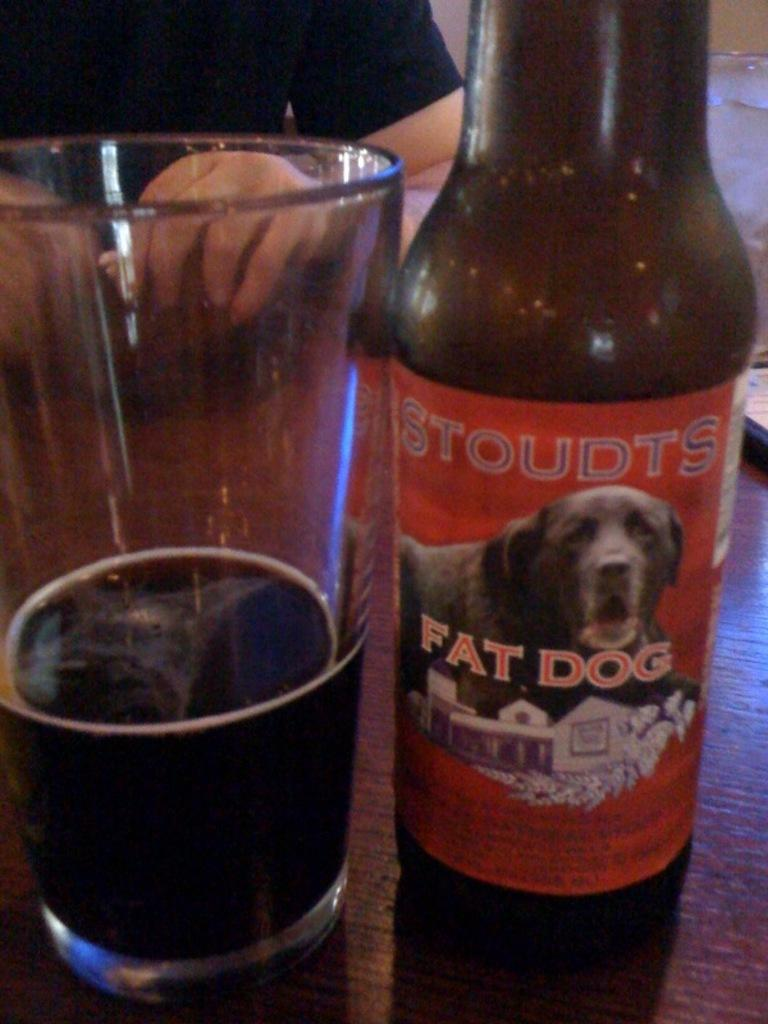<image>
Offer a succinct explanation of the picture presented. Beer brand from Stouts Fat Dog, which is about 1/4 poured into a glass cup. 